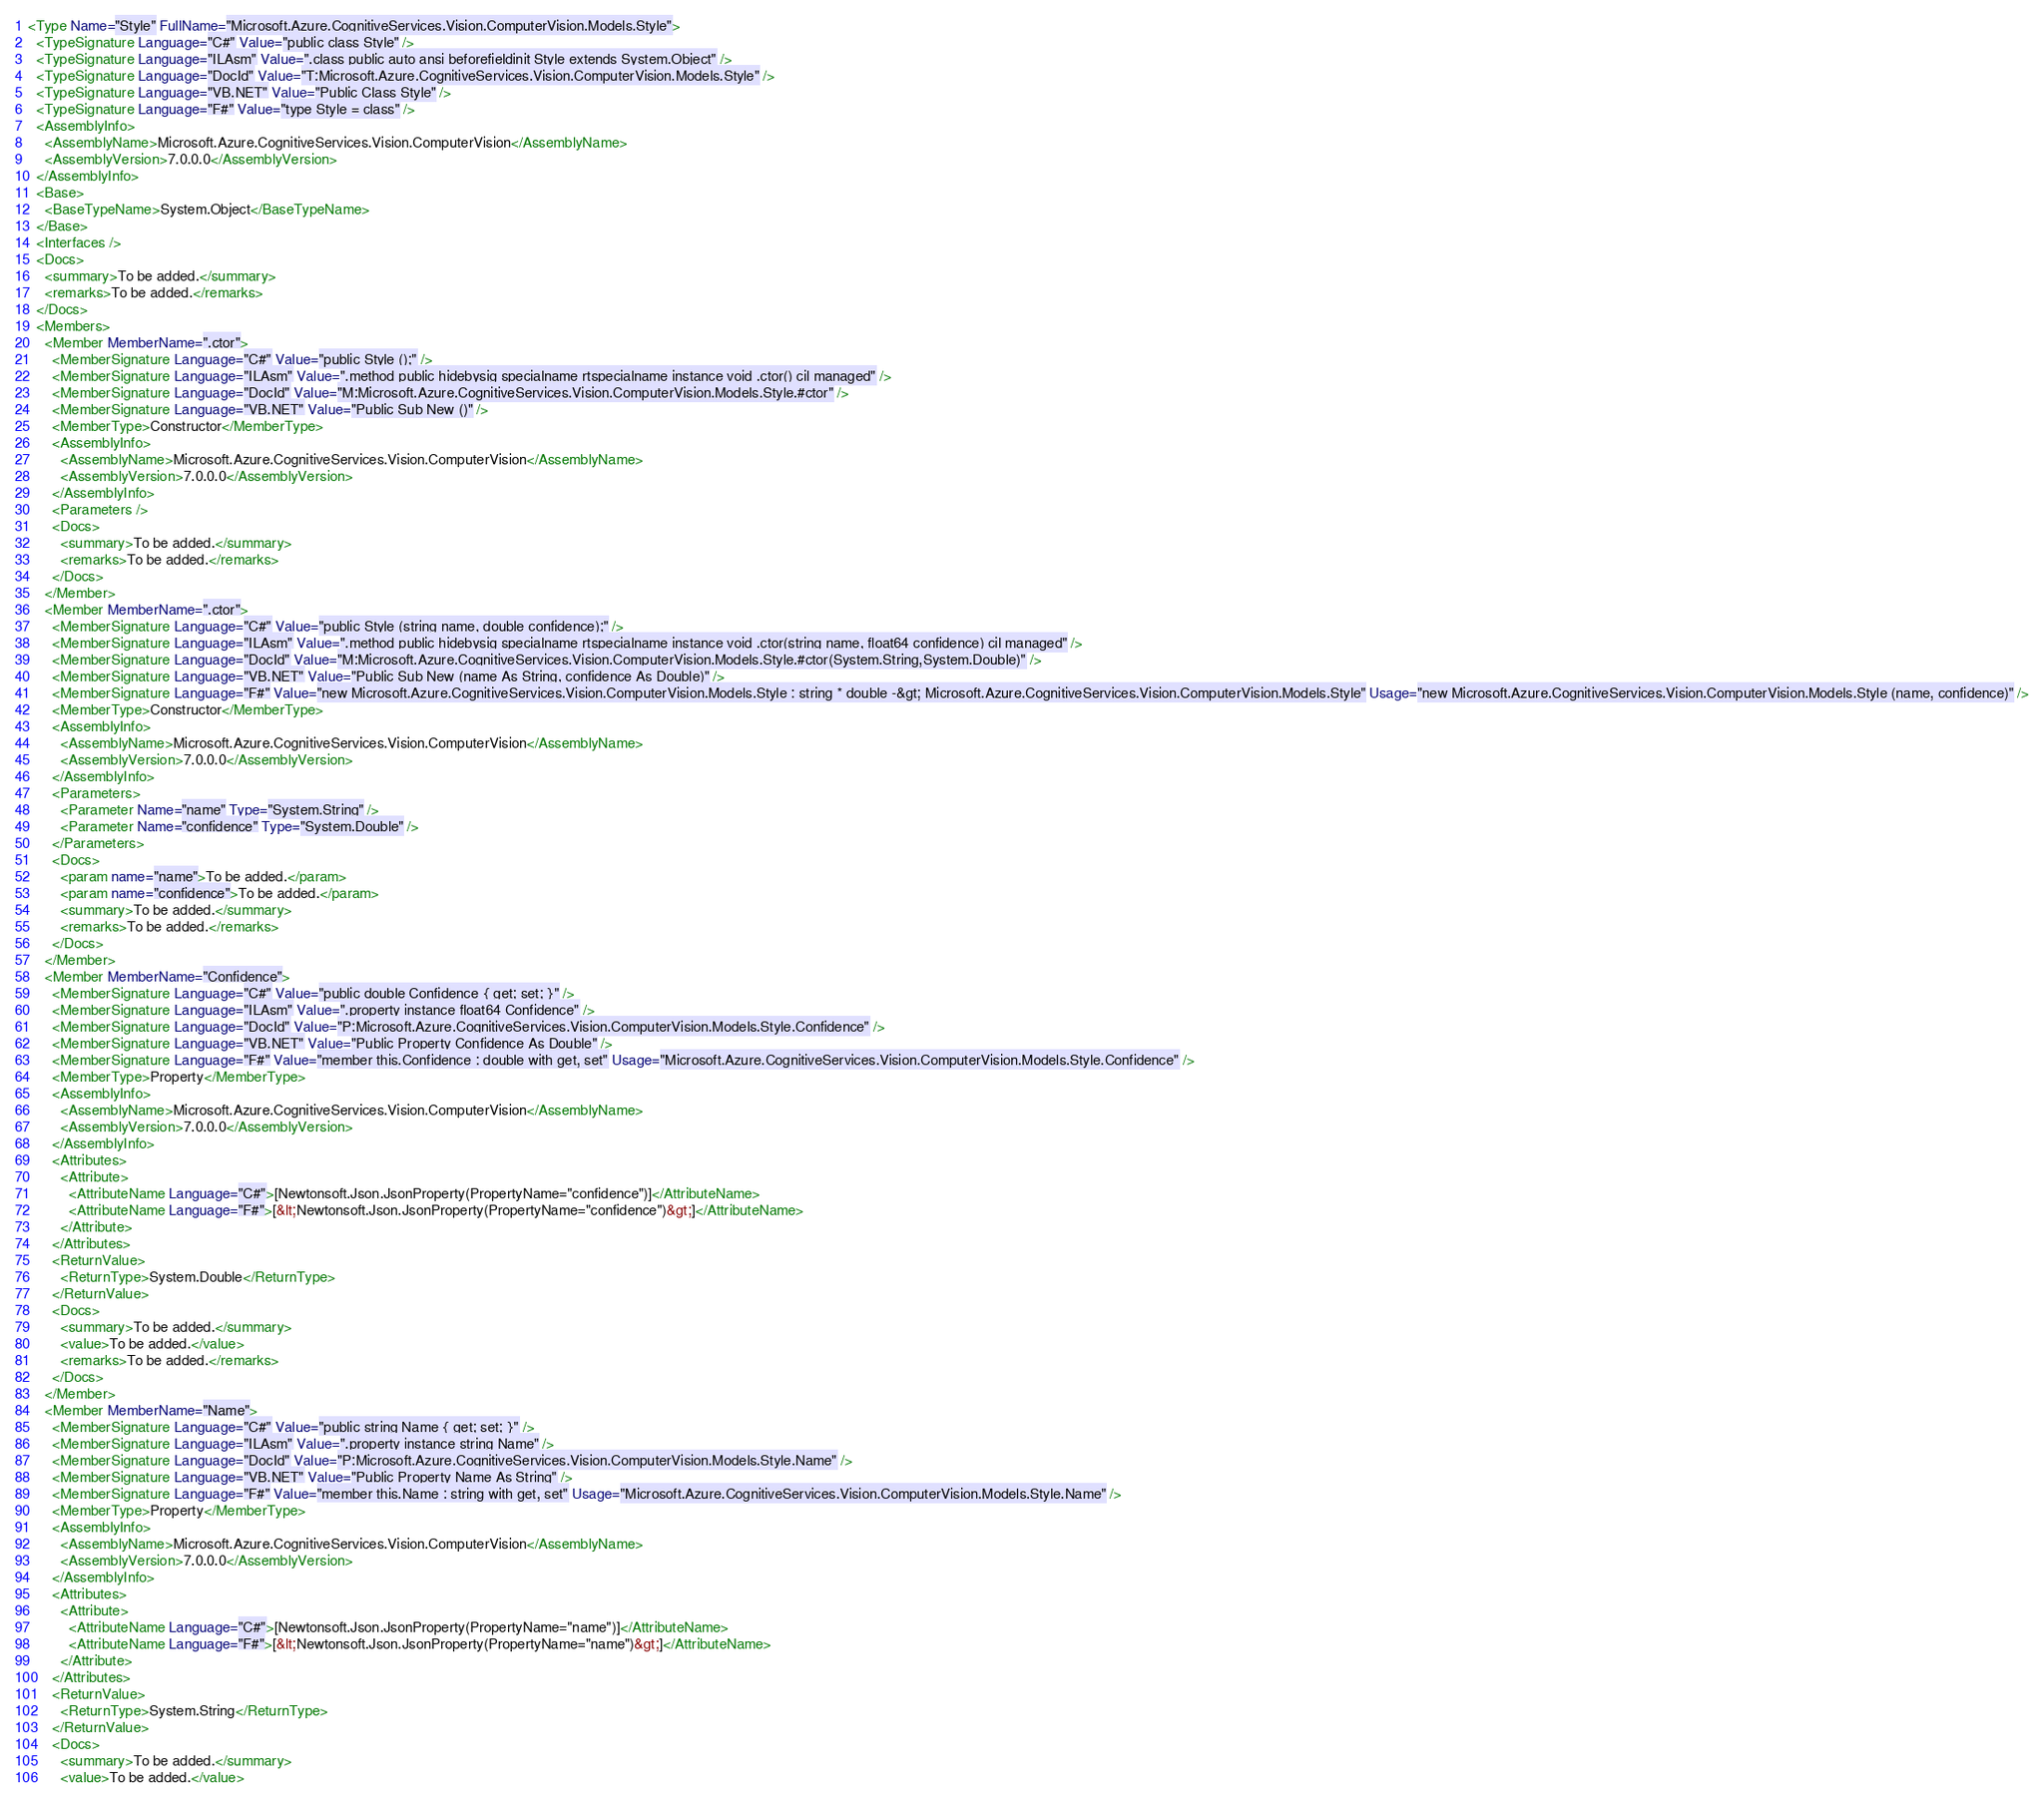Convert code to text. <code><loc_0><loc_0><loc_500><loc_500><_XML_><Type Name="Style" FullName="Microsoft.Azure.CognitiveServices.Vision.ComputerVision.Models.Style">
  <TypeSignature Language="C#" Value="public class Style" />
  <TypeSignature Language="ILAsm" Value=".class public auto ansi beforefieldinit Style extends System.Object" />
  <TypeSignature Language="DocId" Value="T:Microsoft.Azure.CognitiveServices.Vision.ComputerVision.Models.Style" />
  <TypeSignature Language="VB.NET" Value="Public Class Style" />
  <TypeSignature Language="F#" Value="type Style = class" />
  <AssemblyInfo>
    <AssemblyName>Microsoft.Azure.CognitiveServices.Vision.ComputerVision</AssemblyName>
    <AssemblyVersion>7.0.0.0</AssemblyVersion>
  </AssemblyInfo>
  <Base>
    <BaseTypeName>System.Object</BaseTypeName>
  </Base>
  <Interfaces />
  <Docs>
    <summary>To be added.</summary>
    <remarks>To be added.</remarks>
  </Docs>
  <Members>
    <Member MemberName=".ctor">
      <MemberSignature Language="C#" Value="public Style ();" />
      <MemberSignature Language="ILAsm" Value=".method public hidebysig specialname rtspecialname instance void .ctor() cil managed" />
      <MemberSignature Language="DocId" Value="M:Microsoft.Azure.CognitiveServices.Vision.ComputerVision.Models.Style.#ctor" />
      <MemberSignature Language="VB.NET" Value="Public Sub New ()" />
      <MemberType>Constructor</MemberType>
      <AssemblyInfo>
        <AssemblyName>Microsoft.Azure.CognitiveServices.Vision.ComputerVision</AssemblyName>
        <AssemblyVersion>7.0.0.0</AssemblyVersion>
      </AssemblyInfo>
      <Parameters />
      <Docs>
        <summary>To be added.</summary>
        <remarks>To be added.</remarks>
      </Docs>
    </Member>
    <Member MemberName=".ctor">
      <MemberSignature Language="C#" Value="public Style (string name, double confidence);" />
      <MemberSignature Language="ILAsm" Value=".method public hidebysig specialname rtspecialname instance void .ctor(string name, float64 confidence) cil managed" />
      <MemberSignature Language="DocId" Value="M:Microsoft.Azure.CognitiveServices.Vision.ComputerVision.Models.Style.#ctor(System.String,System.Double)" />
      <MemberSignature Language="VB.NET" Value="Public Sub New (name As String, confidence As Double)" />
      <MemberSignature Language="F#" Value="new Microsoft.Azure.CognitiveServices.Vision.ComputerVision.Models.Style : string * double -&gt; Microsoft.Azure.CognitiveServices.Vision.ComputerVision.Models.Style" Usage="new Microsoft.Azure.CognitiveServices.Vision.ComputerVision.Models.Style (name, confidence)" />
      <MemberType>Constructor</MemberType>
      <AssemblyInfo>
        <AssemblyName>Microsoft.Azure.CognitiveServices.Vision.ComputerVision</AssemblyName>
        <AssemblyVersion>7.0.0.0</AssemblyVersion>
      </AssemblyInfo>
      <Parameters>
        <Parameter Name="name" Type="System.String" />
        <Parameter Name="confidence" Type="System.Double" />
      </Parameters>
      <Docs>
        <param name="name">To be added.</param>
        <param name="confidence">To be added.</param>
        <summary>To be added.</summary>
        <remarks>To be added.</remarks>
      </Docs>
    </Member>
    <Member MemberName="Confidence">
      <MemberSignature Language="C#" Value="public double Confidence { get; set; }" />
      <MemberSignature Language="ILAsm" Value=".property instance float64 Confidence" />
      <MemberSignature Language="DocId" Value="P:Microsoft.Azure.CognitiveServices.Vision.ComputerVision.Models.Style.Confidence" />
      <MemberSignature Language="VB.NET" Value="Public Property Confidence As Double" />
      <MemberSignature Language="F#" Value="member this.Confidence : double with get, set" Usage="Microsoft.Azure.CognitiveServices.Vision.ComputerVision.Models.Style.Confidence" />
      <MemberType>Property</MemberType>
      <AssemblyInfo>
        <AssemblyName>Microsoft.Azure.CognitiveServices.Vision.ComputerVision</AssemblyName>
        <AssemblyVersion>7.0.0.0</AssemblyVersion>
      </AssemblyInfo>
      <Attributes>
        <Attribute>
          <AttributeName Language="C#">[Newtonsoft.Json.JsonProperty(PropertyName="confidence")]</AttributeName>
          <AttributeName Language="F#">[&lt;Newtonsoft.Json.JsonProperty(PropertyName="confidence")&gt;]</AttributeName>
        </Attribute>
      </Attributes>
      <ReturnValue>
        <ReturnType>System.Double</ReturnType>
      </ReturnValue>
      <Docs>
        <summary>To be added.</summary>
        <value>To be added.</value>
        <remarks>To be added.</remarks>
      </Docs>
    </Member>
    <Member MemberName="Name">
      <MemberSignature Language="C#" Value="public string Name { get; set; }" />
      <MemberSignature Language="ILAsm" Value=".property instance string Name" />
      <MemberSignature Language="DocId" Value="P:Microsoft.Azure.CognitiveServices.Vision.ComputerVision.Models.Style.Name" />
      <MemberSignature Language="VB.NET" Value="Public Property Name As String" />
      <MemberSignature Language="F#" Value="member this.Name : string with get, set" Usage="Microsoft.Azure.CognitiveServices.Vision.ComputerVision.Models.Style.Name" />
      <MemberType>Property</MemberType>
      <AssemblyInfo>
        <AssemblyName>Microsoft.Azure.CognitiveServices.Vision.ComputerVision</AssemblyName>
        <AssemblyVersion>7.0.0.0</AssemblyVersion>
      </AssemblyInfo>
      <Attributes>
        <Attribute>
          <AttributeName Language="C#">[Newtonsoft.Json.JsonProperty(PropertyName="name")]</AttributeName>
          <AttributeName Language="F#">[&lt;Newtonsoft.Json.JsonProperty(PropertyName="name")&gt;]</AttributeName>
        </Attribute>
      </Attributes>
      <ReturnValue>
        <ReturnType>System.String</ReturnType>
      </ReturnValue>
      <Docs>
        <summary>To be added.</summary>
        <value>To be added.</value></code> 